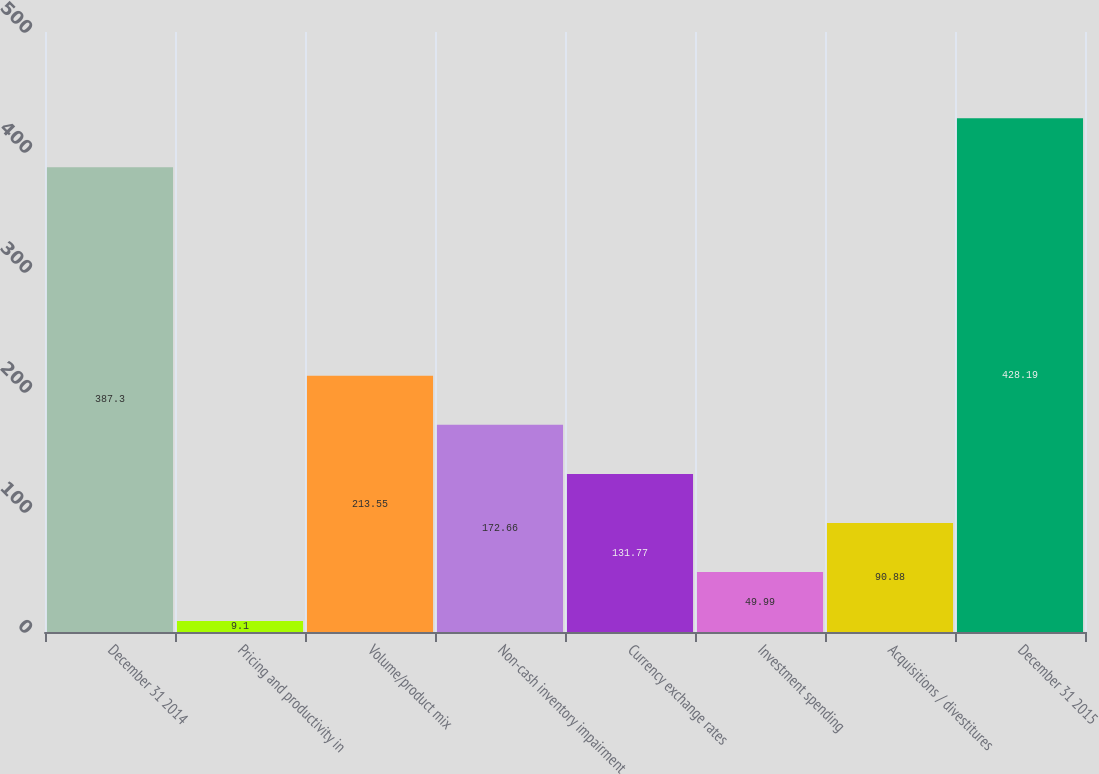Convert chart to OTSL. <chart><loc_0><loc_0><loc_500><loc_500><bar_chart><fcel>December 31 2014<fcel>Pricing and productivity in<fcel>Volume/product mix<fcel>Non-cash inventory impairment<fcel>Currency exchange rates<fcel>Investment spending<fcel>Acquisitions / divestitures<fcel>December 31 2015<nl><fcel>387.3<fcel>9.1<fcel>213.55<fcel>172.66<fcel>131.77<fcel>49.99<fcel>90.88<fcel>428.19<nl></chart> 